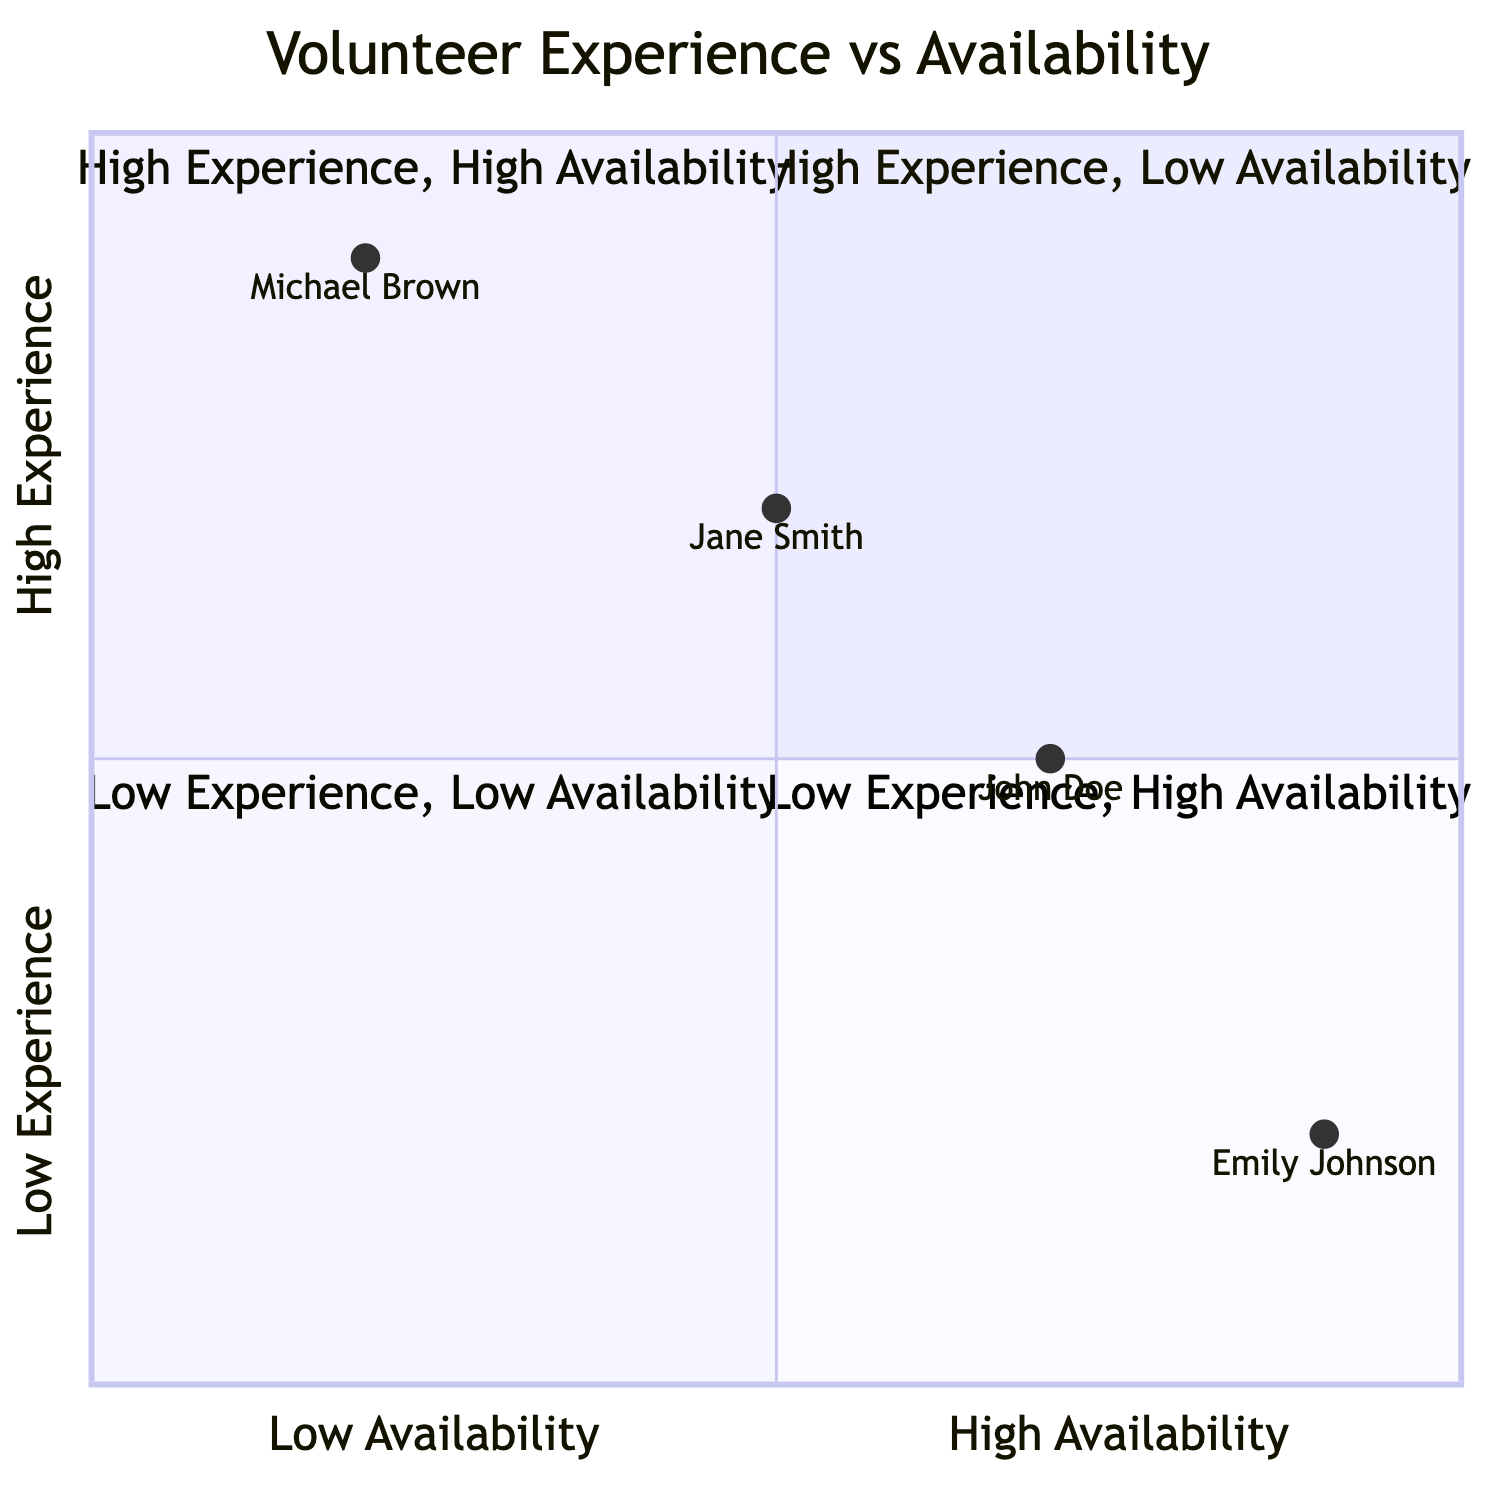what is the availability level of Jane Smith? By locating Jane Smith on the quadrant chart, she is positioned at the point representing Moderate Availability.
Answer: Moderate how many volunteers are in the High Experience, High Availability quadrant? The quadrant chart indicates that only Jane Smith fits the criteria for High Experience and High Availability.
Answer: 1 which volunteer has the lowest ability to handle stress? Emily Johnson is located in the quadrant corresponding to Low Ability to Handle Stress, indicating she has the lowest ability among the volunteers listed.
Answer: Emily Johnson what is the experience level of John Doe? John Doe is positioned in the quadrant that represents Intermediate Experience, confirming his level.
Answer: Intermediate which quadrant contains volunteers with low experience and very high availability? The quadrant that is defined by Low Experience and Very High Availability will have Emily Johnson as the only volunteer present.
Answer: Quadrant 4 how does the experience level of Michael Brown relate to his availability? Michael Brown, categorized as having Expert Experience, is also shown to have Low Availability, indicating a contrast between his high experience and low availability.
Answer: Contrast what percentage of volunteers are advanced or expert in experience? The volunteers Jane Smith and Michael Brown have experience levels categorized as Advanced and Expert, making up 50% of the total volunteers listed.
Answer: 50% in which quadrant is John Doe located? John Doe is mapped in Quadrant 2, which is characterized by High Experience and Moderate Availability.
Answer: Quadrant 2 how many volunteers have very high availability? From the provided data, only Emily Johnson is identified as having Very High Availability.
Answer: 1 